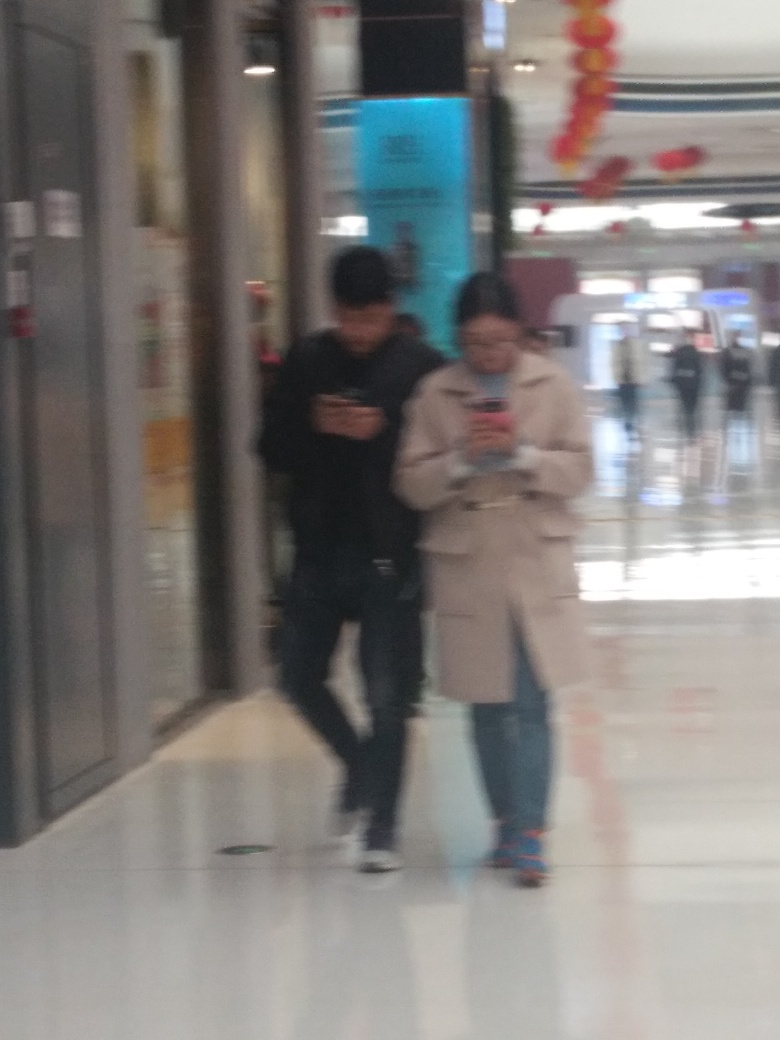What might be the reason for the blurriness of this image? The blurriness of the image could be due to several factors such as camera movement, subject movement, or incorrect focus at the time the photo was taken. It could also result from a low shutter speed or a camera lens issue.  Could you describe the setting or location depicted in the image? Despite the lack of clarity due to blurriness, it appears to show two individuals walking in an indoor setting, possibly a mall or a public building, with shops and various signage visible in the background. 